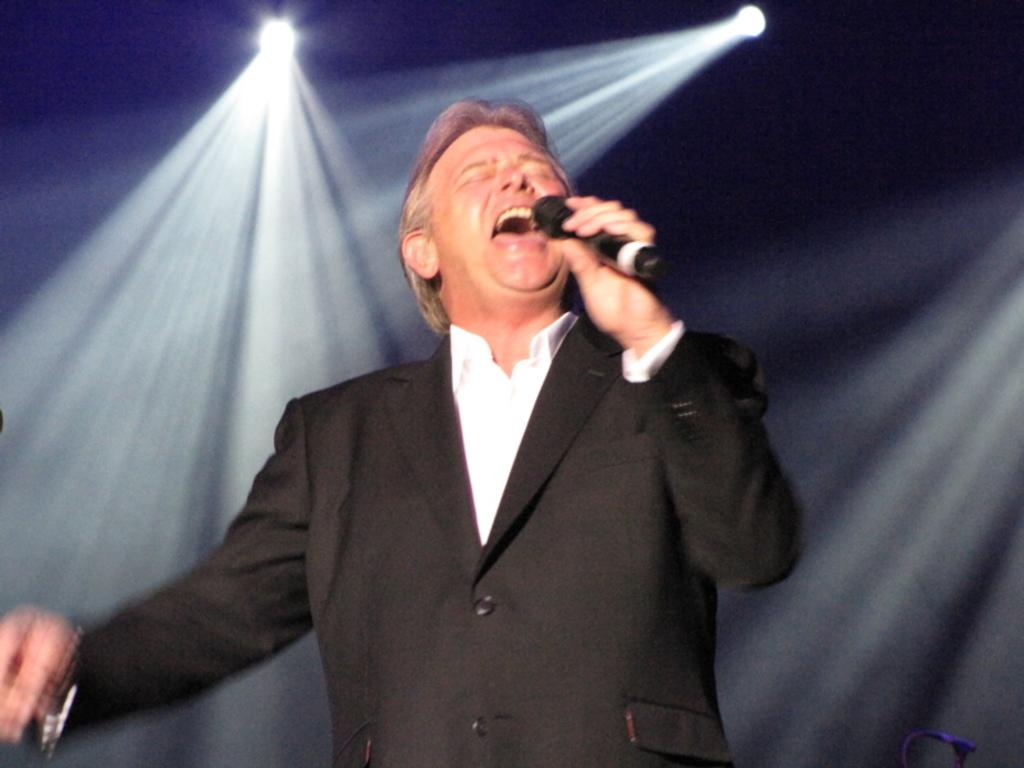What is the man in the image doing? The man is holding a microphone in his hand and appears to be singing. What object is the man holding in the image? The man is holding a microphone in his hand. What can be seen in the background of the image? There are lights visible in the image. What type of seat is the man using while singing in the image? There is no seat visible in the image; the man appears to be standing while singing. 